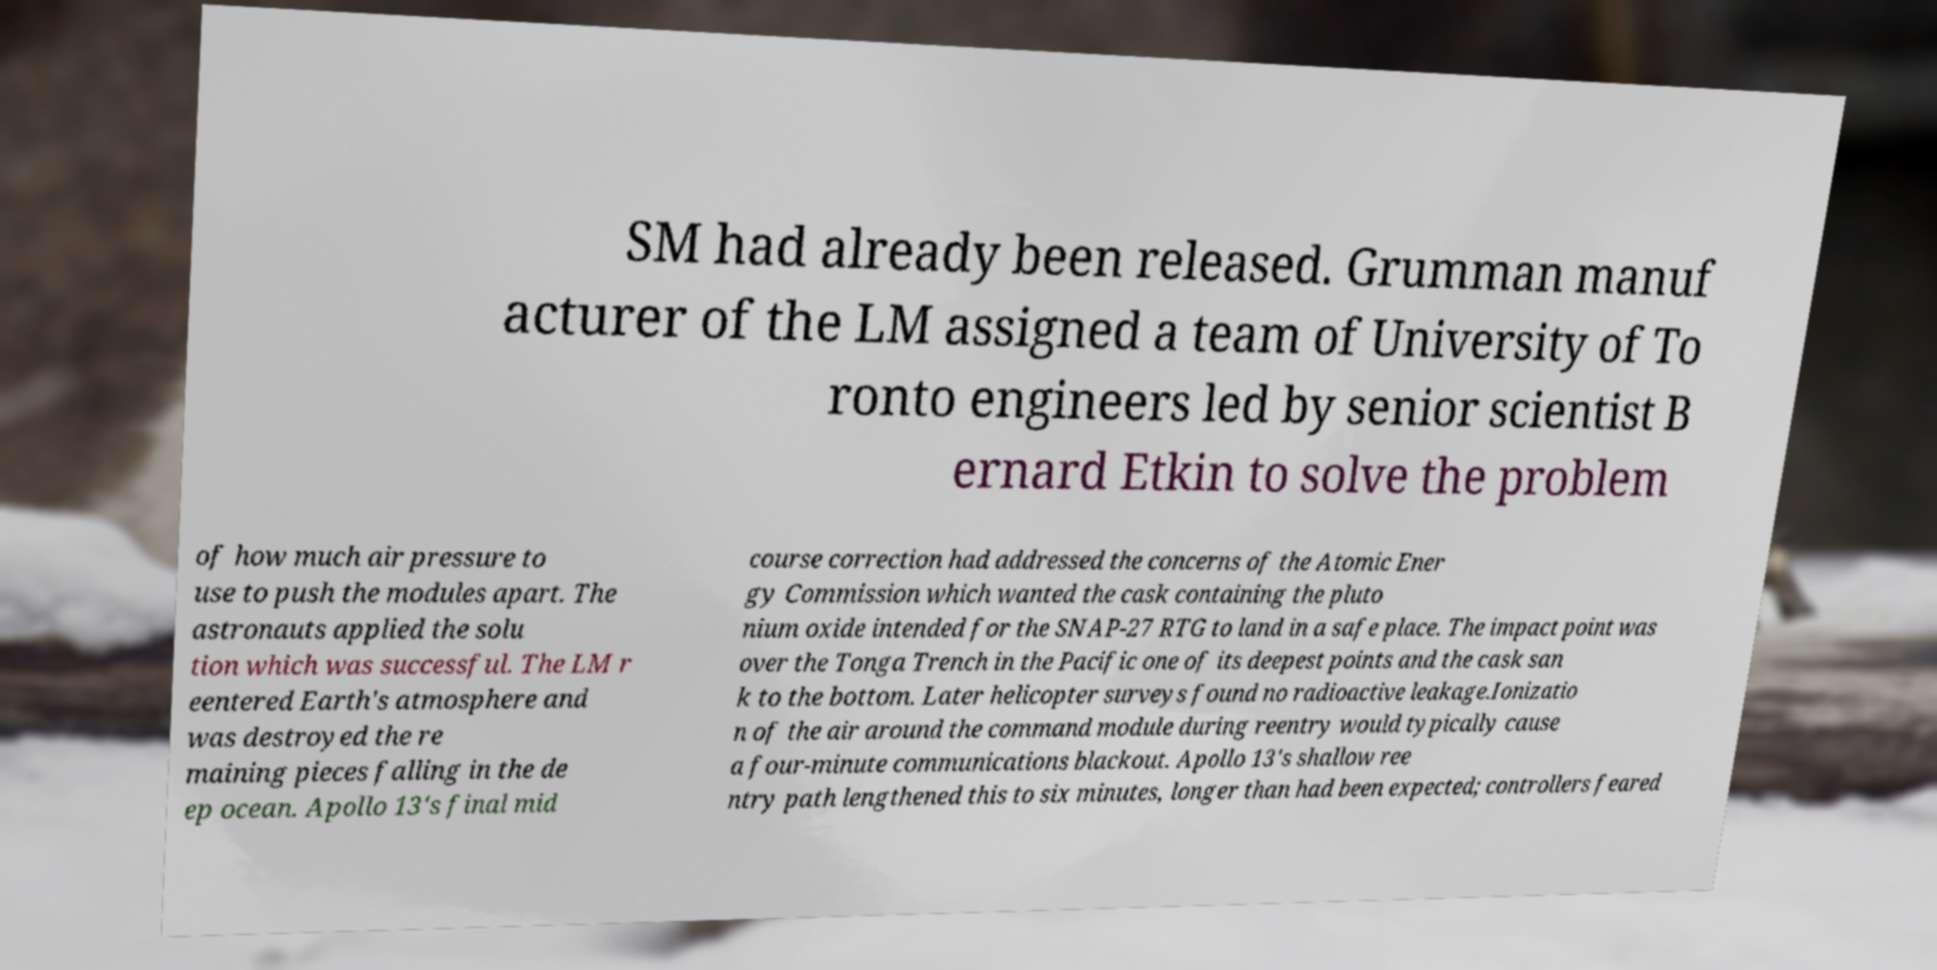What messages or text are displayed in this image? I need them in a readable, typed format. SM had already been released. Grumman manuf acturer of the LM assigned a team of University of To ronto engineers led by senior scientist B ernard Etkin to solve the problem of how much air pressure to use to push the modules apart. The astronauts applied the solu tion which was successful. The LM r eentered Earth's atmosphere and was destroyed the re maining pieces falling in the de ep ocean. Apollo 13's final mid course correction had addressed the concerns of the Atomic Ener gy Commission which wanted the cask containing the pluto nium oxide intended for the SNAP-27 RTG to land in a safe place. The impact point was over the Tonga Trench in the Pacific one of its deepest points and the cask san k to the bottom. Later helicopter surveys found no radioactive leakage.Ionizatio n of the air around the command module during reentry would typically cause a four-minute communications blackout. Apollo 13's shallow ree ntry path lengthened this to six minutes, longer than had been expected; controllers feared 